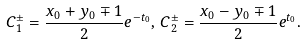<formula> <loc_0><loc_0><loc_500><loc_500>C _ { 1 } ^ { \pm } = \frac { x _ { 0 } + y _ { 0 } \mp 1 } { 2 } e ^ { - t _ { 0 } } , \, C _ { 2 } ^ { \pm } = \frac { x _ { 0 } - y _ { 0 } \mp 1 } { 2 } e ^ { t _ { 0 } } .</formula> 